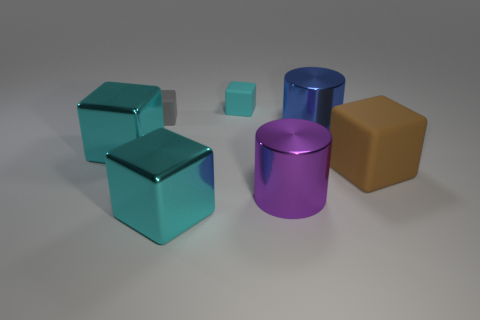How many cyan blocks must be subtracted to get 1 cyan blocks? 2 Subtract all purple cylinders. How many cyan cubes are left? 3 Subtract all brown rubber cubes. How many cubes are left? 4 Subtract all brown blocks. How many blocks are left? 4 Subtract all gray cubes. Subtract all yellow cylinders. How many cubes are left? 4 Add 2 gray rubber things. How many objects exist? 9 Subtract all cubes. How many objects are left? 2 Add 1 blocks. How many blocks exist? 6 Subtract 1 purple cylinders. How many objects are left? 6 Subtract all yellow shiny things. Subtract all large cyan shiny things. How many objects are left? 5 